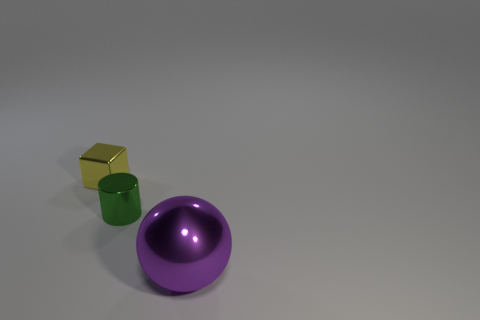Add 1 large gray matte cylinders. How many objects exist? 4 Subtract all cylinders. How many objects are left? 2 Add 1 brown blocks. How many brown blocks exist? 1 Subtract 1 green cylinders. How many objects are left? 2 Subtract all big spheres. Subtract all balls. How many objects are left? 1 Add 3 yellow cubes. How many yellow cubes are left? 4 